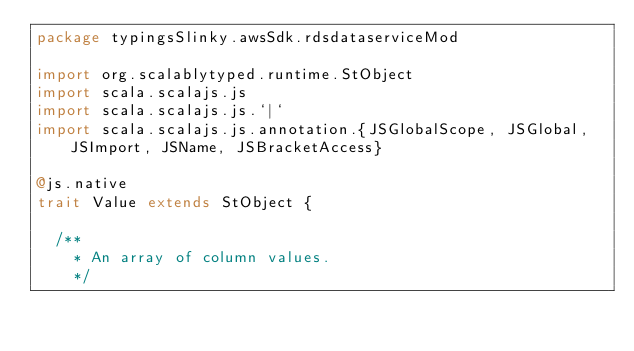<code> <loc_0><loc_0><loc_500><loc_500><_Scala_>package typingsSlinky.awsSdk.rdsdataserviceMod

import org.scalablytyped.runtime.StObject
import scala.scalajs.js
import scala.scalajs.js.`|`
import scala.scalajs.js.annotation.{JSGlobalScope, JSGlobal, JSImport, JSName, JSBracketAccess}

@js.native
trait Value extends StObject {
  
  /**
    * An array of column values.
    */</code> 